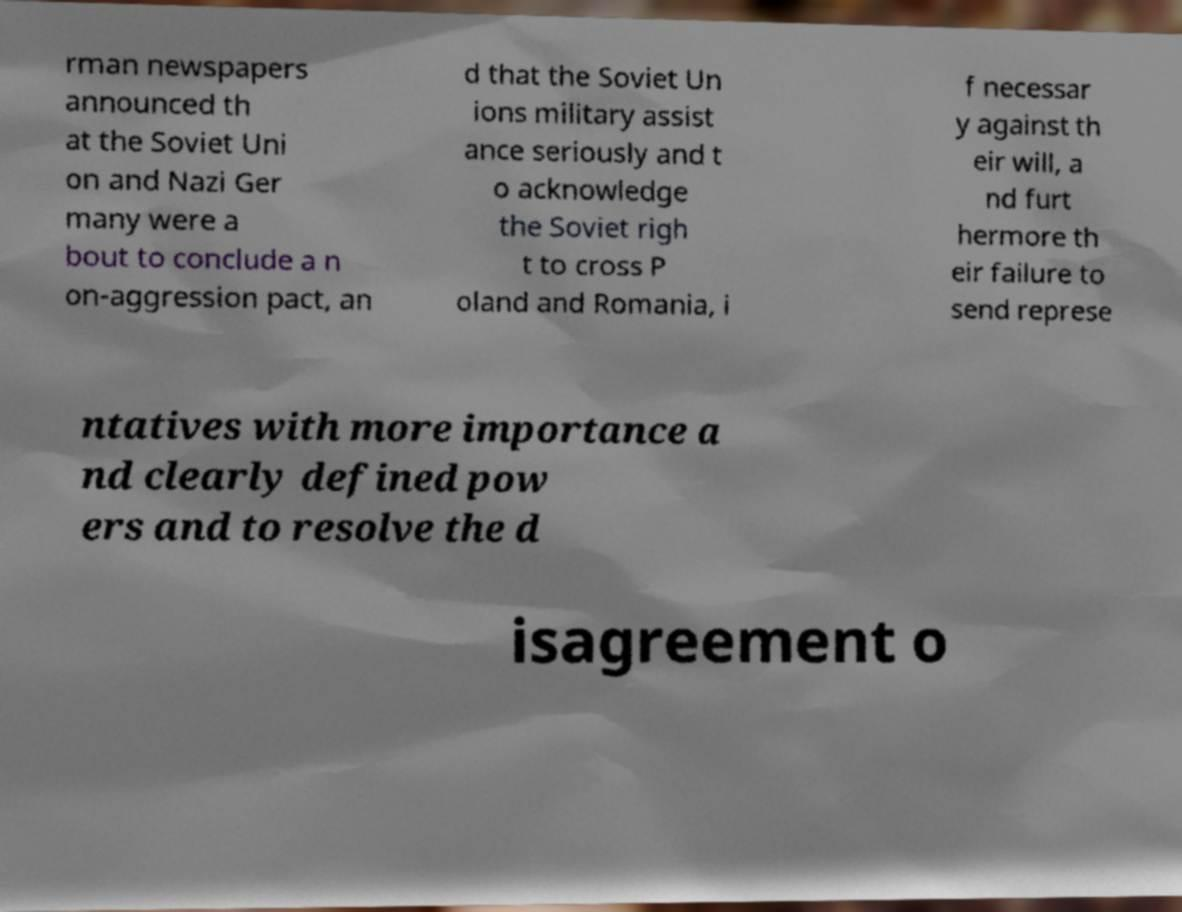Can you accurately transcribe the text from the provided image for me? rman newspapers announced th at the Soviet Uni on and Nazi Ger many were a bout to conclude a n on-aggression pact, an d that the Soviet Un ions military assist ance seriously and t o acknowledge the Soviet righ t to cross P oland and Romania, i f necessar y against th eir will, a nd furt hermore th eir failure to send represe ntatives with more importance a nd clearly defined pow ers and to resolve the d isagreement o 